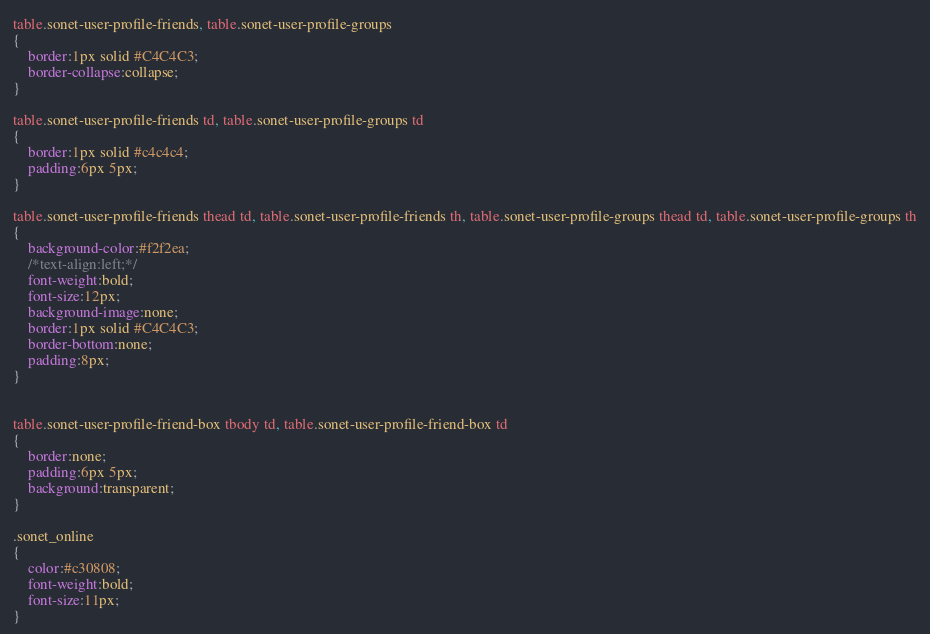<code> <loc_0><loc_0><loc_500><loc_500><_CSS_>table.sonet-user-profile-friends, table.sonet-user-profile-groups
{
	border:1px solid #C4C4C3;
	border-collapse:collapse;
}

table.sonet-user-profile-friends td, table.sonet-user-profile-groups td
{
	border:1px solid #c4c4c4;
	padding:6px 5px;
}

table.sonet-user-profile-friends thead td, table.sonet-user-profile-friends th, table.sonet-user-profile-groups thead td, table.sonet-user-profile-groups th
{
	background-color:#f2f2ea;
	/*text-align:left;*/
	font-weight:bold;
	font-size:12px;
	background-image:none;
	border:1px solid #C4C4C3;
	border-bottom:none;
	padding:8px;
}


table.sonet-user-profile-friend-box tbody td, table.sonet-user-profile-friend-box td
{
	border:none;
	padding:6px 5px;
	background:transparent;
}

.sonet_online
{
	color:#c30808;
	font-weight:bold;
	font-size:11px;
}
</code> 